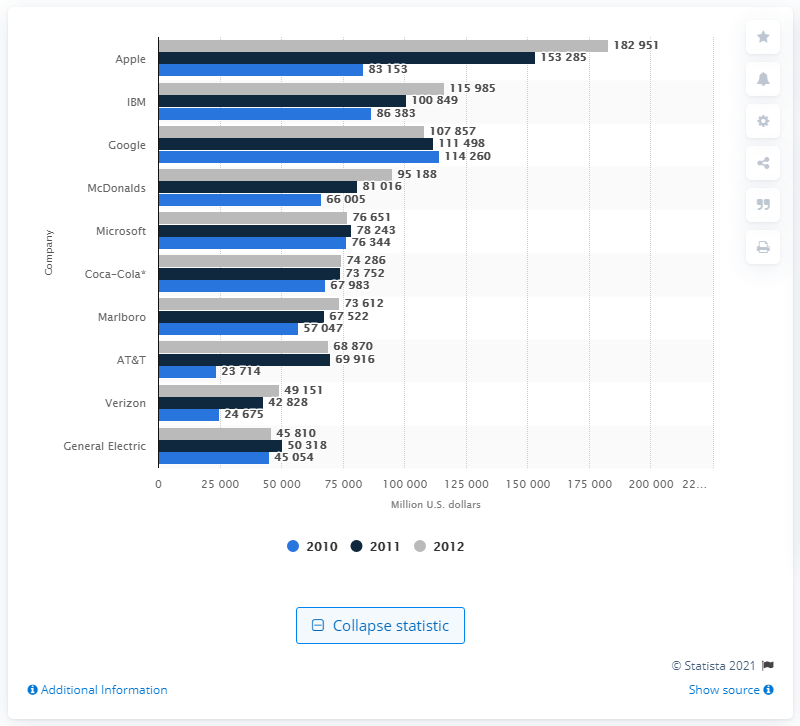Indicate a few pertinent items in this graphic. In 2011, Apple's net worth in dollars was approximately 153,285. In 2011, Apple was the brand with the highest value. 